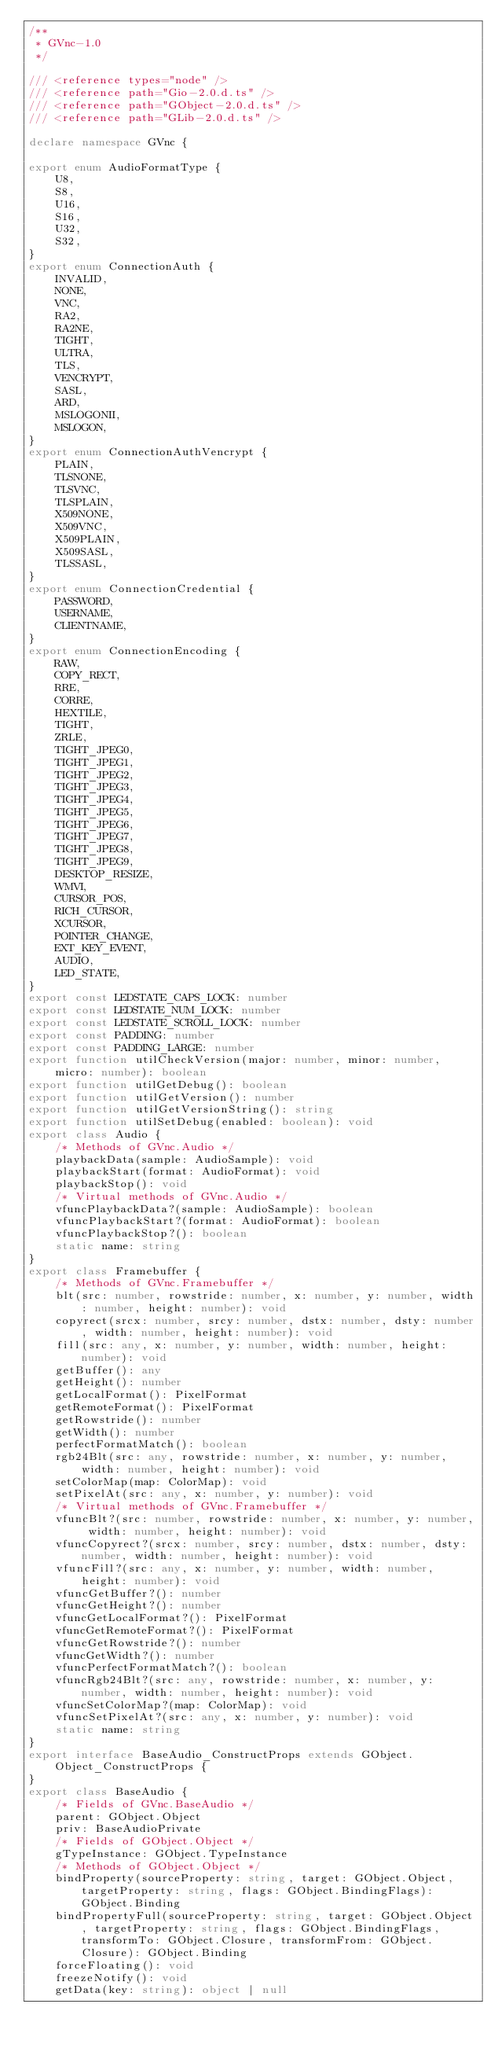Convert code to text. <code><loc_0><loc_0><loc_500><loc_500><_TypeScript_>/**
 * GVnc-1.0
 */

/// <reference types="node" />
/// <reference path="Gio-2.0.d.ts" />
/// <reference path="GObject-2.0.d.ts" />
/// <reference path="GLib-2.0.d.ts" />

declare namespace GVnc {

export enum AudioFormatType {
    U8,
    S8,
    U16,
    S16,
    U32,
    S32,
}
export enum ConnectionAuth {
    INVALID,
    NONE,
    VNC,
    RA2,
    RA2NE,
    TIGHT,
    ULTRA,
    TLS,
    VENCRYPT,
    SASL,
    ARD,
    MSLOGONII,
    MSLOGON,
}
export enum ConnectionAuthVencrypt {
    PLAIN,
    TLSNONE,
    TLSVNC,
    TLSPLAIN,
    X509NONE,
    X509VNC,
    X509PLAIN,
    X509SASL,
    TLSSASL,
}
export enum ConnectionCredential {
    PASSWORD,
    USERNAME,
    CLIENTNAME,
}
export enum ConnectionEncoding {
    RAW,
    COPY_RECT,
    RRE,
    CORRE,
    HEXTILE,
    TIGHT,
    ZRLE,
    TIGHT_JPEG0,
    TIGHT_JPEG1,
    TIGHT_JPEG2,
    TIGHT_JPEG3,
    TIGHT_JPEG4,
    TIGHT_JPEG5,
    TIGHT_JPEG6,
    TIGHT_JPEG7,
    TIGHT_JPEG8,
    TIGHT_JPEG9,
    DESKTOP_RESIZE,
    WMVI,
    CURSOR_POS,
    RICH_CURSOR,
    XCURSOR,
    POINTER_CHANGE,
    EXT_KEY_EVENT,
    AUDIO,
    LED_STATE,
}
export const LEDSTATE_CAPS_LOCK: number
export const LEDSTATE_NUM_LOCK: number
export const LEDSTATE_SCROLL_LOCK: number
export const PADDING: number
export const PADDING_LARGE: number
export function utilCheckVersion(major: number, minor: number, micro: number): boolean
export function utilGetDebug(): boolean
export function utilGetVersion(): number
export function utilGetVersionString(): string
export function utilSetDebug(enabled: boolean): void
export class Audio {
    /* Methods of GVnc.Audio */
    playbackData(sample: AudioSample): void
    playbackStart(format: AudioFormat): void
    playbackStop(): void
    /* Virtual methods of GVnc.Audio */
    vfuncPlaybackData?(sample: AudioSample): boolean
    vfuncPlaybackStart?(format: AudioFormat): boolean
    vfuncPlaybackStop?(): boolean
    static name: string
}
export class Framebuffer {
    /* Methods of GVnc.Framebuffer */
    blt(src: number, rowstride: number, x: number, y: number, width: number, height: number): void
    copyrect(srcx: number, srcy: number, dstx: number, dsty: number, width: number, height: number): void
    fill(src: any, x: number, y: number, width: number, height: number): void
    getBuffer(): any
    getHeight(): number
    getLocalFormat(): PixelFormat
    getRemoteFormat(): PixelFormat
    getRowstride(): number
    getWidth(): number
    perfectFormatMatch(): boolean
    rgb24Blt(src: any, rowstride: number, x: number, y: number, width: number, height: number): void
    setColorMap(map: ColorMap): void
    setPixelAt(src: any, x: number, y: number): void
    /* Virtual methods of GVnc.Framebuffer */
    vfuncBlt?(src: number, rowstride: number, x: number, y: number, width: number, height: number): void
    vfuncCopyrect?(srcx: number, srcy: number, dstx: number, dsty: number, width: number, height: number): void
    vfuncFill?(src: any, x: number, y: number, width: number, height: number): void
    vfuncGetBuffer?(): number
    vfuncGetHeight?(): number
    vfuncGetLocalFormat?(): PixelFormat
    vfuncGetRemoteFormat?(): PixelFormat
    vfuncGetRowstride?(): number
    vfuncGetWidth?(): number
    vfuncPerfectFormatMatch?(): boolean
    vfuncRgb24Blt?(src: any, rowstride: number, x: number, y: number, width: number, height: number): void
    vfuncSetColorMap?(map: ColorMap): void
    vfuncSetPixelAt?(src: any, x: number, y: number): void
    static name: string
}
export interface BaseAudio_ConstructProps extends GObject.Object_ConstructProps {
}
export class BaseAudio {
    /* Fields of GVnc.BaseAudio */
    parent: GObject.Object
    priv: BaseAudioPrivate
    /* Fields of GObject.Object */
    gTypeInstance: GObject.TypeInstance
    /* Methods of GObject.Object */
    bindProperty(sourceProperty: string, target: GObject.Object, targetProperty: string, flags: GObject.BindingFlags): GObject.Binding
    bindPropertyFull(sourceProperty: string, target: GObject.Object, targetProperty: string, flags: GObject.BindingFlags, transformTo: GObject.Closure, transformFrom: GObject.Closure): GObject.Binding
    forceFloating(): void
    freezeNotify(): void
    getData(key: string): object | null</code> 